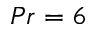<formula> <loc_0><loc_0><loc_500><loc_500>P r = 6</formula> 